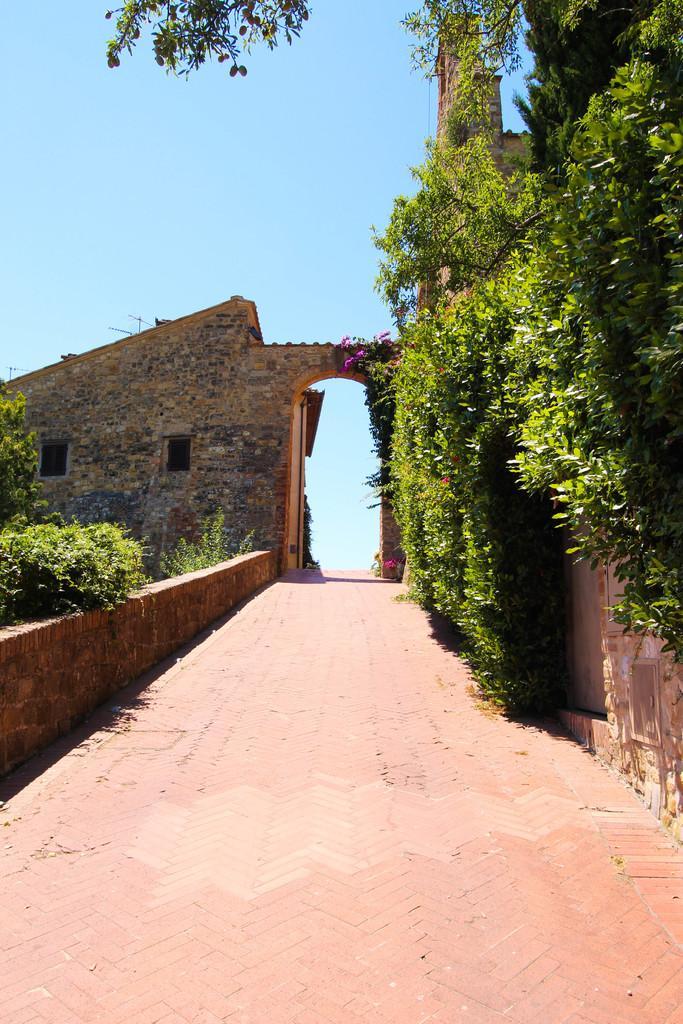In one or two sentences, can you explain what this image depicts? In this image on the right side there are plants. On the left side there is a wall and there are plants. In the background there is a wall and there are flowers. 